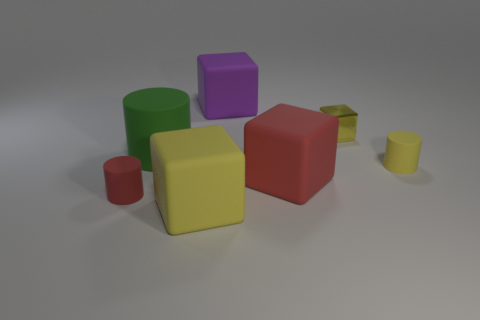Add 1 large yellow matte things. How many objects exist? 8 Subtract all cylinders. How many objects are left? 4 Subtract 0 brown cubes. How many objects are left? 7 Subtract all tiny blue cylinders. Subtract all purple rubber blocks. How many objects are left? 6 Add 1 tiny cubes. How many tiny cubes are left? 2 Add 7 green objects. How many green objects exist? 8 